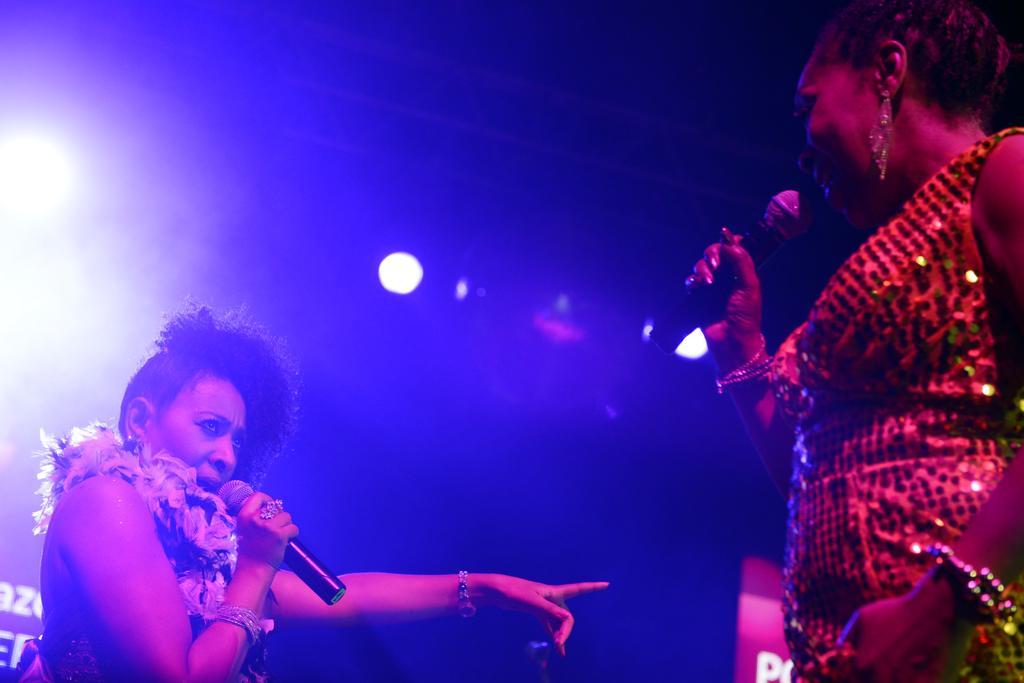Can you describe this image briefly? In this picture we can see two women holding microphones in their hands. We can see some text visible on the right and left side of the image. There are a few lights visible in the background. 